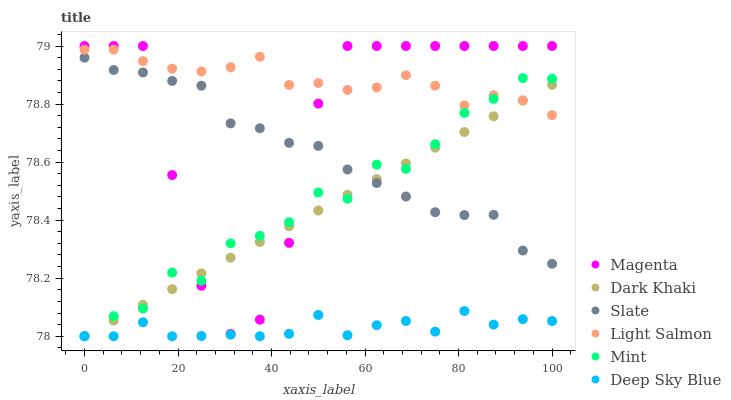Does Deep Sky Blue have the minimum area under the curve?
Answer yes or no. Yes. Does Light Salmon have the maximum area under the curve?
Answer yes or no. Yes. Does Slate have the minimum area under the curve?
Answer yes or no. No. Does Slate have the maximum area under the curve?
Answer yes or no. No. Is Dark Khaki the smoothest?
Answer yes or no. Yes. Is Magenta the roughest?
Answer yes or no. Yes. Is Slate the smoothest?
Answer yes or no. No. Is Slate the roughest?
Answer yes or no. No. Does Dark Khaki have the lowest value?
Answer yes or no. Yes. Does Slate have the lowest value?
Answer yes or no. No. Does Magenta have the highest value?
Answer yes or no. Yes. Does Slate have the highest value?
Answer yes or no. No. Is Slate less than Light Salmon?
Answer yes or no. Yes. Is Magenta greater than Deep Sky Blue?
Answer yes or no. Yes. Does Deep Sky Blue intersect Dark Khaki?
Answer yes or no. Yes. Is Deep Sky Blue less than Dark Khaki?
Answer yes or no. No. Is Deep Sky Blue greater than Dark Khaki?
Answer yes or no. No. Does Slate intersect Light Salmon?
Answer yes or no. No. 